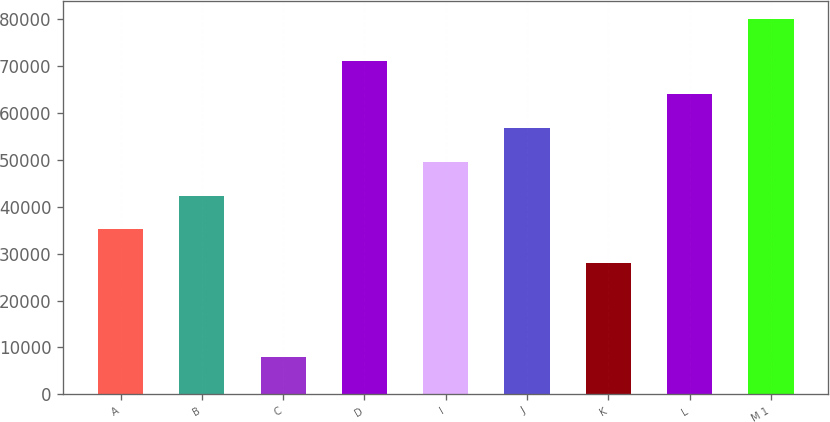Convert chart to OTSL. <chart><loc_0><loc_0><loc_500><loc_500><bar_chart><fcel>A<fcel>B<fcel>C<fcel>D<fcel>I<fcel>J<fcel>K<fcel>L<fcel>M 1<nl><fcel>35200<fcel>42400<fcel>8000<fcel>71200<fcel>49600<fcel>56800<fcel>28000<fcel>64000<fcel>80000<nl></chart> 